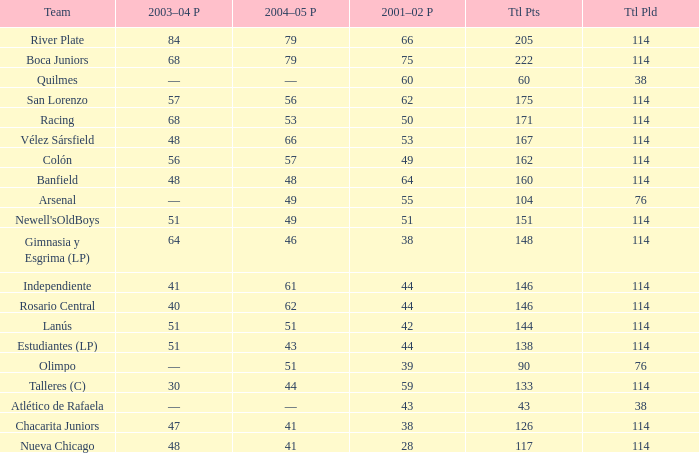Which Team has a Total Pld smaller than 114, and a 2004–05 Pts of 49? Arsenal. 